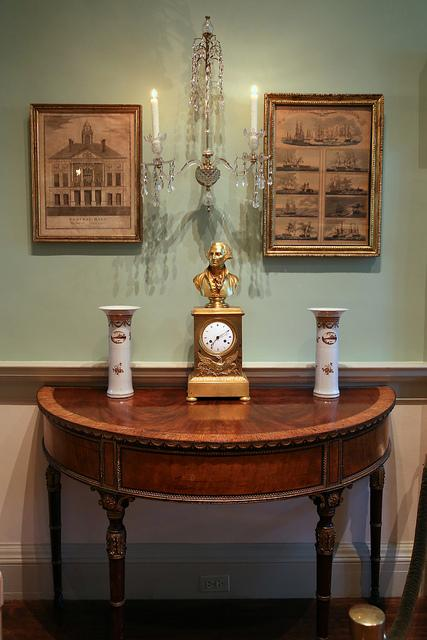How many items on the table are to the left of the clock? Please explain your reasoning. one. There are matching items on both sides of the clock, so there is one on the left and one on the right. 